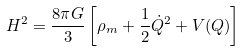Convert formula to latex. <formula><loc_0><loc_0><loc_500><loc_500>H ^ { 2 } = \frac { 8 \pi G } { 3 } \left [ \rho _ { m } + \frac { 1 } { 2 } \dot { Q } ^ { 2 } + V ( Q ) \right ]</formula> 